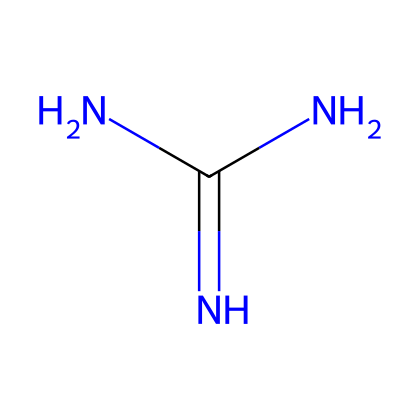What is the name of this chemical? The SMILES representation NC(N)=N corresponds to guanidine, which is a known organic superbase.
Answer: guanidine How many nitrogen atoms are present in guanidine? By examining the SMILES, there are three nitrogen atoms present in the structure; one attached to a carbon, and two in the amino groups.
Answer: three What type of functional groups are present in this chemical? The structure contains one primary amine functional group (NH2) and a guanidino group, which is characterized by the nitrogen-containing structure.
Answer: amine What is the hybridization of the central nitrogen atom in guanidine? The central nitrogen atom is sp2 hybridized because it is bonded to two other nitrogen atoms and one carbon atom, enabling a planar arrangement.
Answer: sp2 How does the structure of guanidine contribute to its basicity? The presence of multiple nitrogen atoms allows for a greater availability of lone pairs, enhancing the ability to accept protons, which enhances basicity.
Answer: multiple nitrogen atoms What is the average bond angle around the central nitrogen in guanidine? Due to the trigonal planar nature of the sp2 hybridization, the bond angles around the central nitrogen atom are approximately 120 degrees.
Answer: 120 degrees How does the structure influence guanidine's role as a superbase? Guanidine’s structure with several basic sites allows it to readily deprotonate various substrates, thus acting as a strong proton acceptor.
Answer: multiple basic sites 